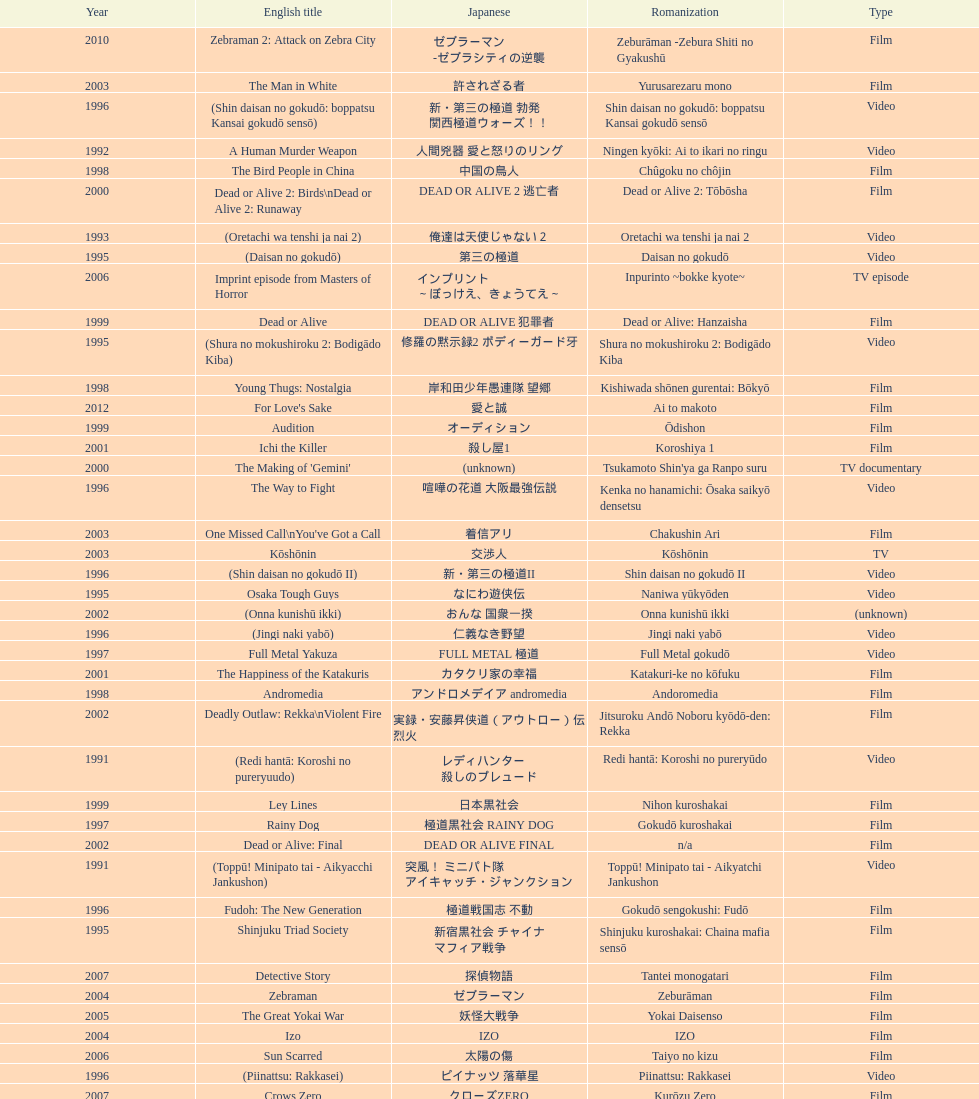State a cinema that was launched earlier than 199 Shinjuku Triad Society. 